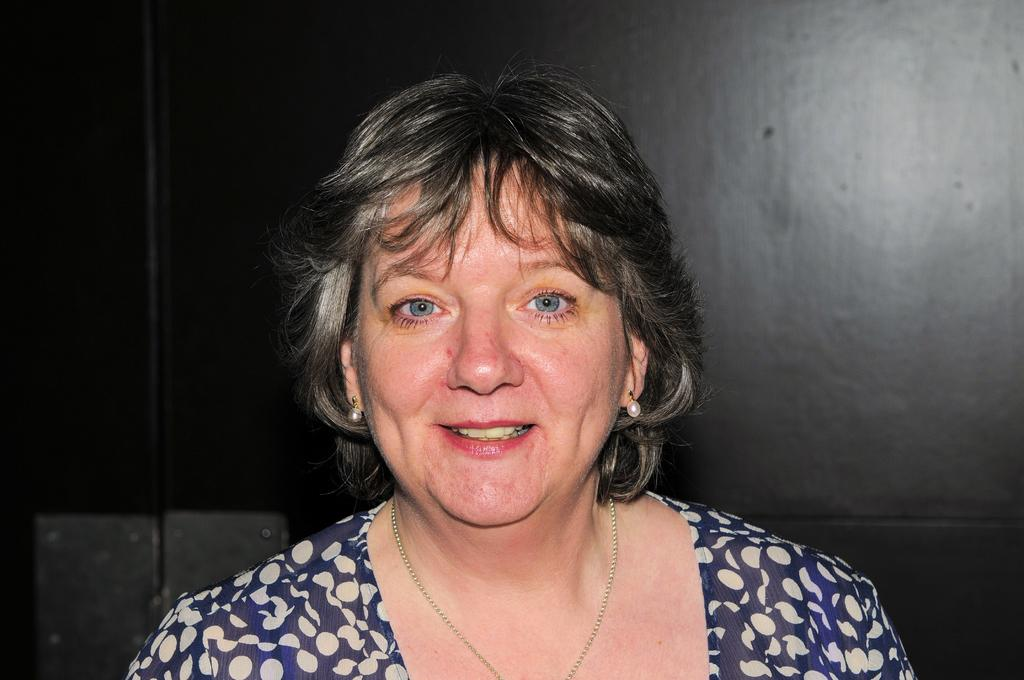Who or what is the main subject in the image? There is a person in the image. What is the person wearing? The person is wearing a blue and cream color dress. What color is the background of the image? A: The background of the image is black. What type of steel structure can be seen in the background of the image? There is no steel structure visible in the image; the background is black. Can you describe the garden or farm setting in the image? There is no garden or farm setting present in the image; it features a person wearing a blue and cream color dress against a black background. 